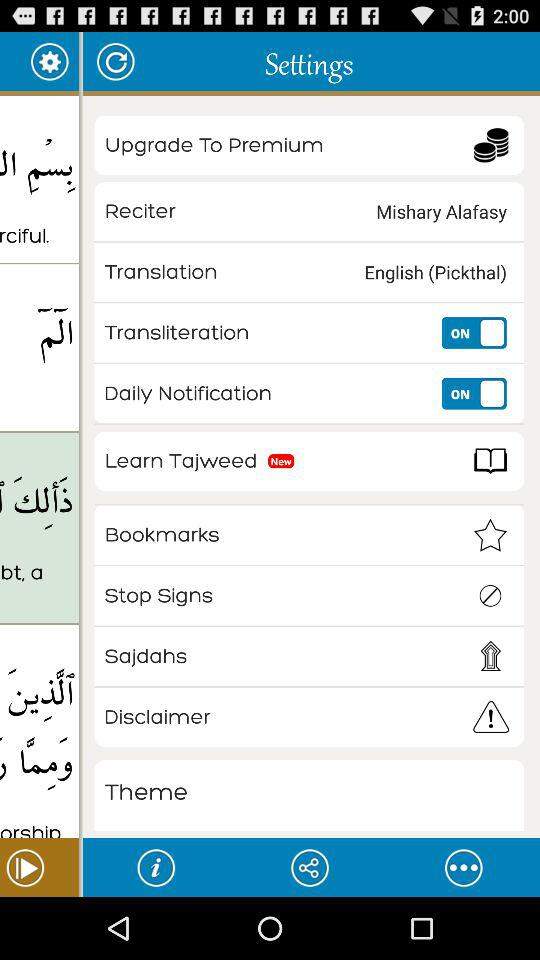What is the status of "Transliteration"? The status is "on". 